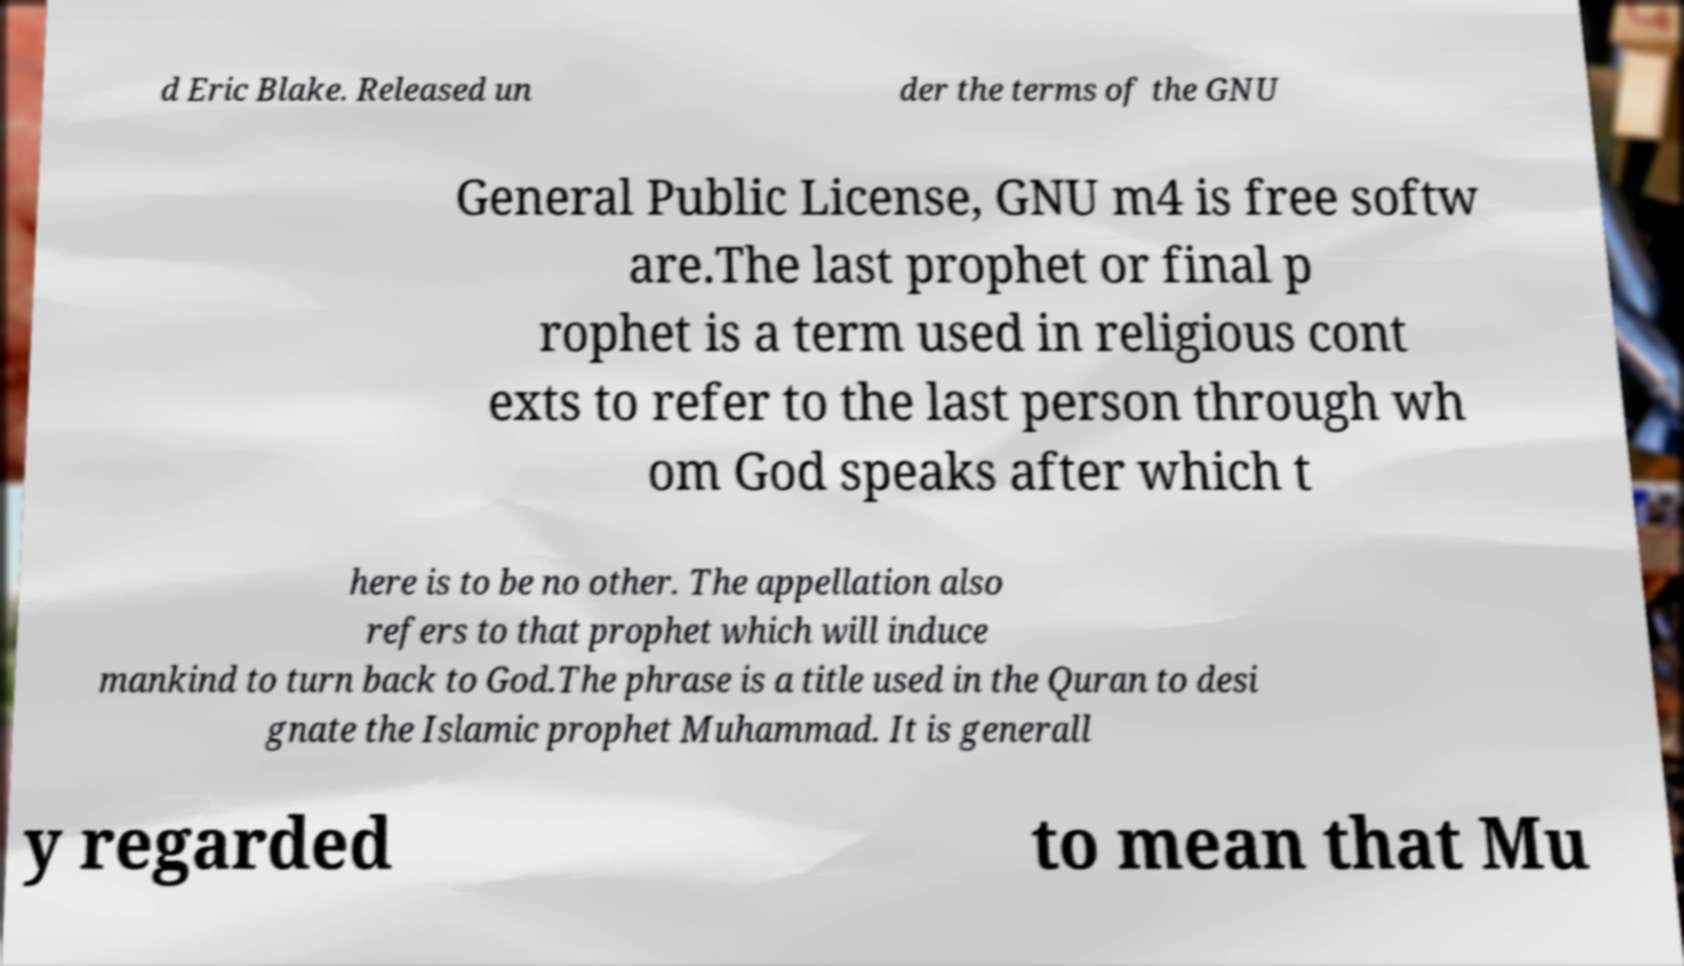Can you accurately transcribe the text from the provided image for me? d Eric Blake. Released un der the terms of the GNU General Public License, GNU m4 is free softw are.The last prophet or final p rophet is a term used in religious cont exts to refer to the last person through wh om God speaks after which t here is to be no other. The appellation also refers to that prophet which will induce mankind to turn back to God.The phrase is a title used in the Quran to desi gnate the Islamic prophet Muhammad. It is generall y regarded to mean that Mu 